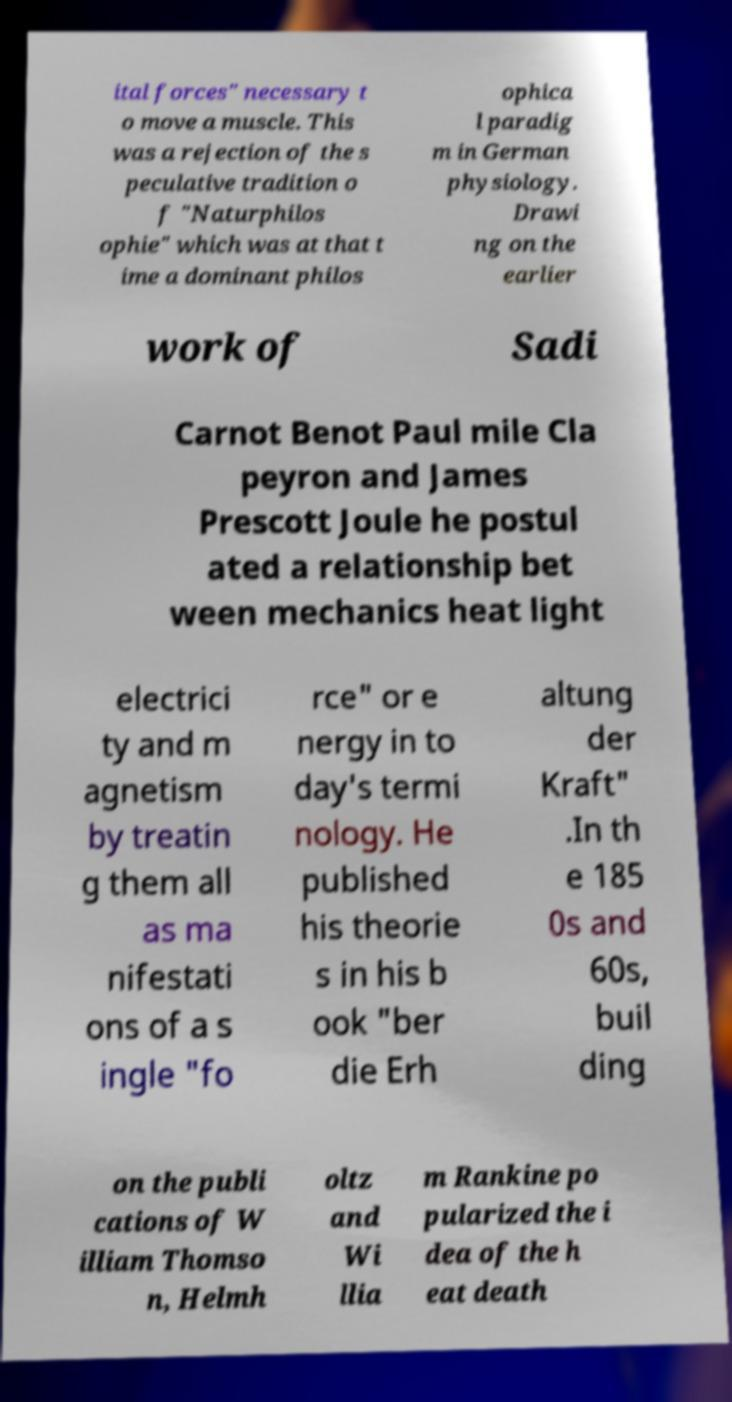Please identify and transcribe the text found in this image. ital forces" necessary t o move a muscle. This was a rejection of the s peculative tradition o f "Naturphilos ophie" which was at that t ime a dominant philos ophica l paradig m in German physiology. Drawi ng on the earlier work of Sadi Carnot Benot Paul mile Cla peyron and James Prescott Joule he postul ated a relationship bet ween mechanics heat light electrici ty and m agnetism by treatin g them all as ma nifestati ons of a s ingle "fo rce" or e nergy in to day's termi nology. He published his theorie s in his b ook "ber die Erh altung der Kraft" .In th e 185 0s and 60s, buil ding on the publi cations of W illiam Thomso n, Helmh oltz and Wi llia m Rankine po pularized the i dea of the h eat death 